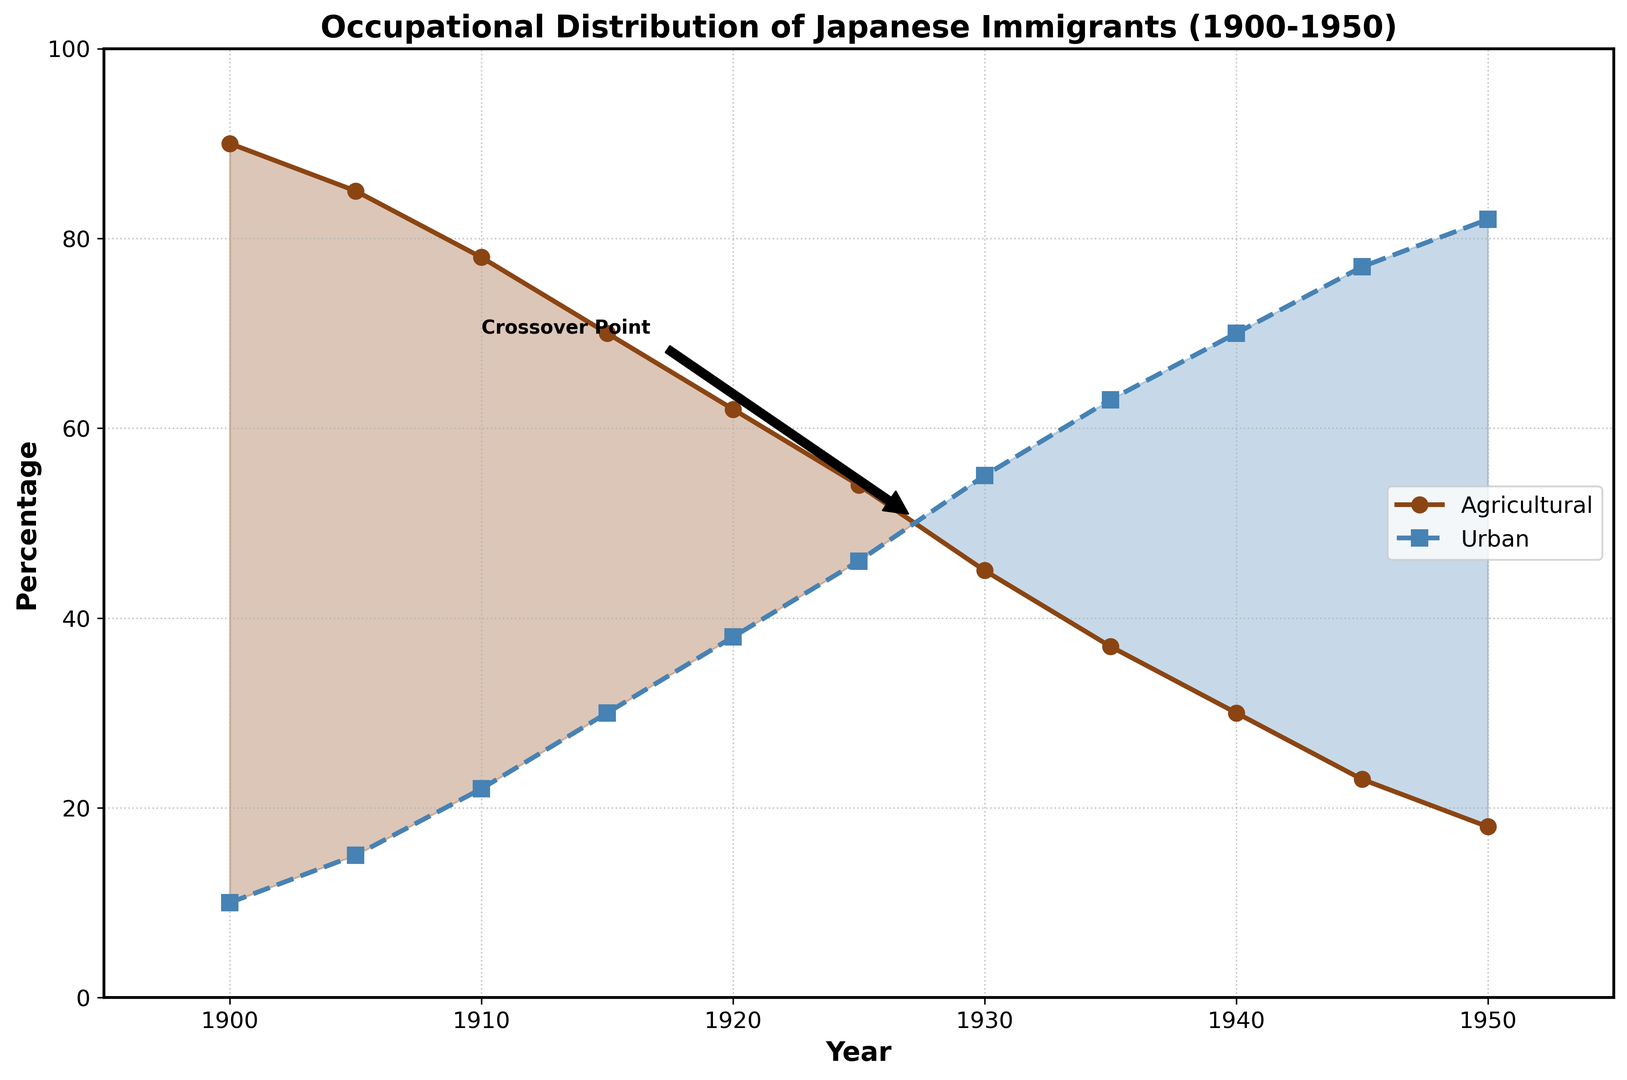What year do agricultural and urban professions reach an equal percentage? To find the crossover point where agricultural and urban professions are equal, locate the year where the two lines (agricultural and urban) intersect on the plot, which is around 1927.5 as annotated in the plot.
Answer: 1927.5 Which profession saw a higher percentage increase from 1900 to 1950? To determine which profession saw a higher increase, compare the percentages in 1900 and 1950 for both professions. For agricultural, it decreased from 90% to 18%, a difference of -72%. For urban, it increased from 10% to 82%, a difference of +72%. Hence, the urban profession saw a higher percentage increase.
Answer: Urban What is the difference in percentage between the two professions in the year 1950? Check the value of each profession in the year 1950: agricultural is 18%, and urban is 82%. The difference is found by subtracting the agricultural percentage from the urban percentage (82% - 18% = 64%).
Answer: 64% During which years did the percentage of the agricultural profession decrease the most? To determine the years with the largest decrease in the percentage of agricultural professions, look at the steepest downwards slopes on the agricultural line in the plot. The largest decreases appear to be between 1900 and 1905, and between 1935 and 1940.
Answer: 1900-1905 and 1935-1940 By how much did the percentage composition change for each profession between 1930 and 1940? For agricultural: in 1930 it was 45%, and by 1940 it was 30%, a decrease of 15%. For urban: in 1930 it was 55%, and by 1940 it was 70%, an increase of 15%.
Answer: 15% What is the average percentage of urban professions from 1900 to 1950? Calculate the average by summing the urban percentages and dividing by the number of years. The sum is (10 + 15 + 22 + 30 + 38 + 46 + 55 + 63 + 70 + 77 + 82) = 508. There are 11 data points, so the average is 508 / 11 = 46.18%.
Answer: 46.18% In what year does the percentage of urban professions first surpass 60%? Observe when the line for urban professions crosses above 60%. According to the plot, this happens in 1935 when urban reaches 63%.
Answer: 1935 Which segment of the plot has the steepest increase in urban professions? Identify the segment where the urban profession line has its steepest upwards slope. From the plot, this steep increase happens between 1930 and 1940.
Answer: 1930-1940 Does the percentage of agricultural professions ever rise above the percentage of urban professions after 1920? Check the plot to see if the agricultural line ever crosses above the urban line after 1920. The agricultural percentage consistently stays below the urban percentage after 1920.
Answer: No What is the difference in percentage points between the agricultural and urban professions in the year 1945? Check the values for both professions in 1945: agricultural is 23%, and urban is 77%. The difference is calculated by subtracting the agricultural percentage from the urban percentage (77% - 23% = 54%).
Answer: 54% 